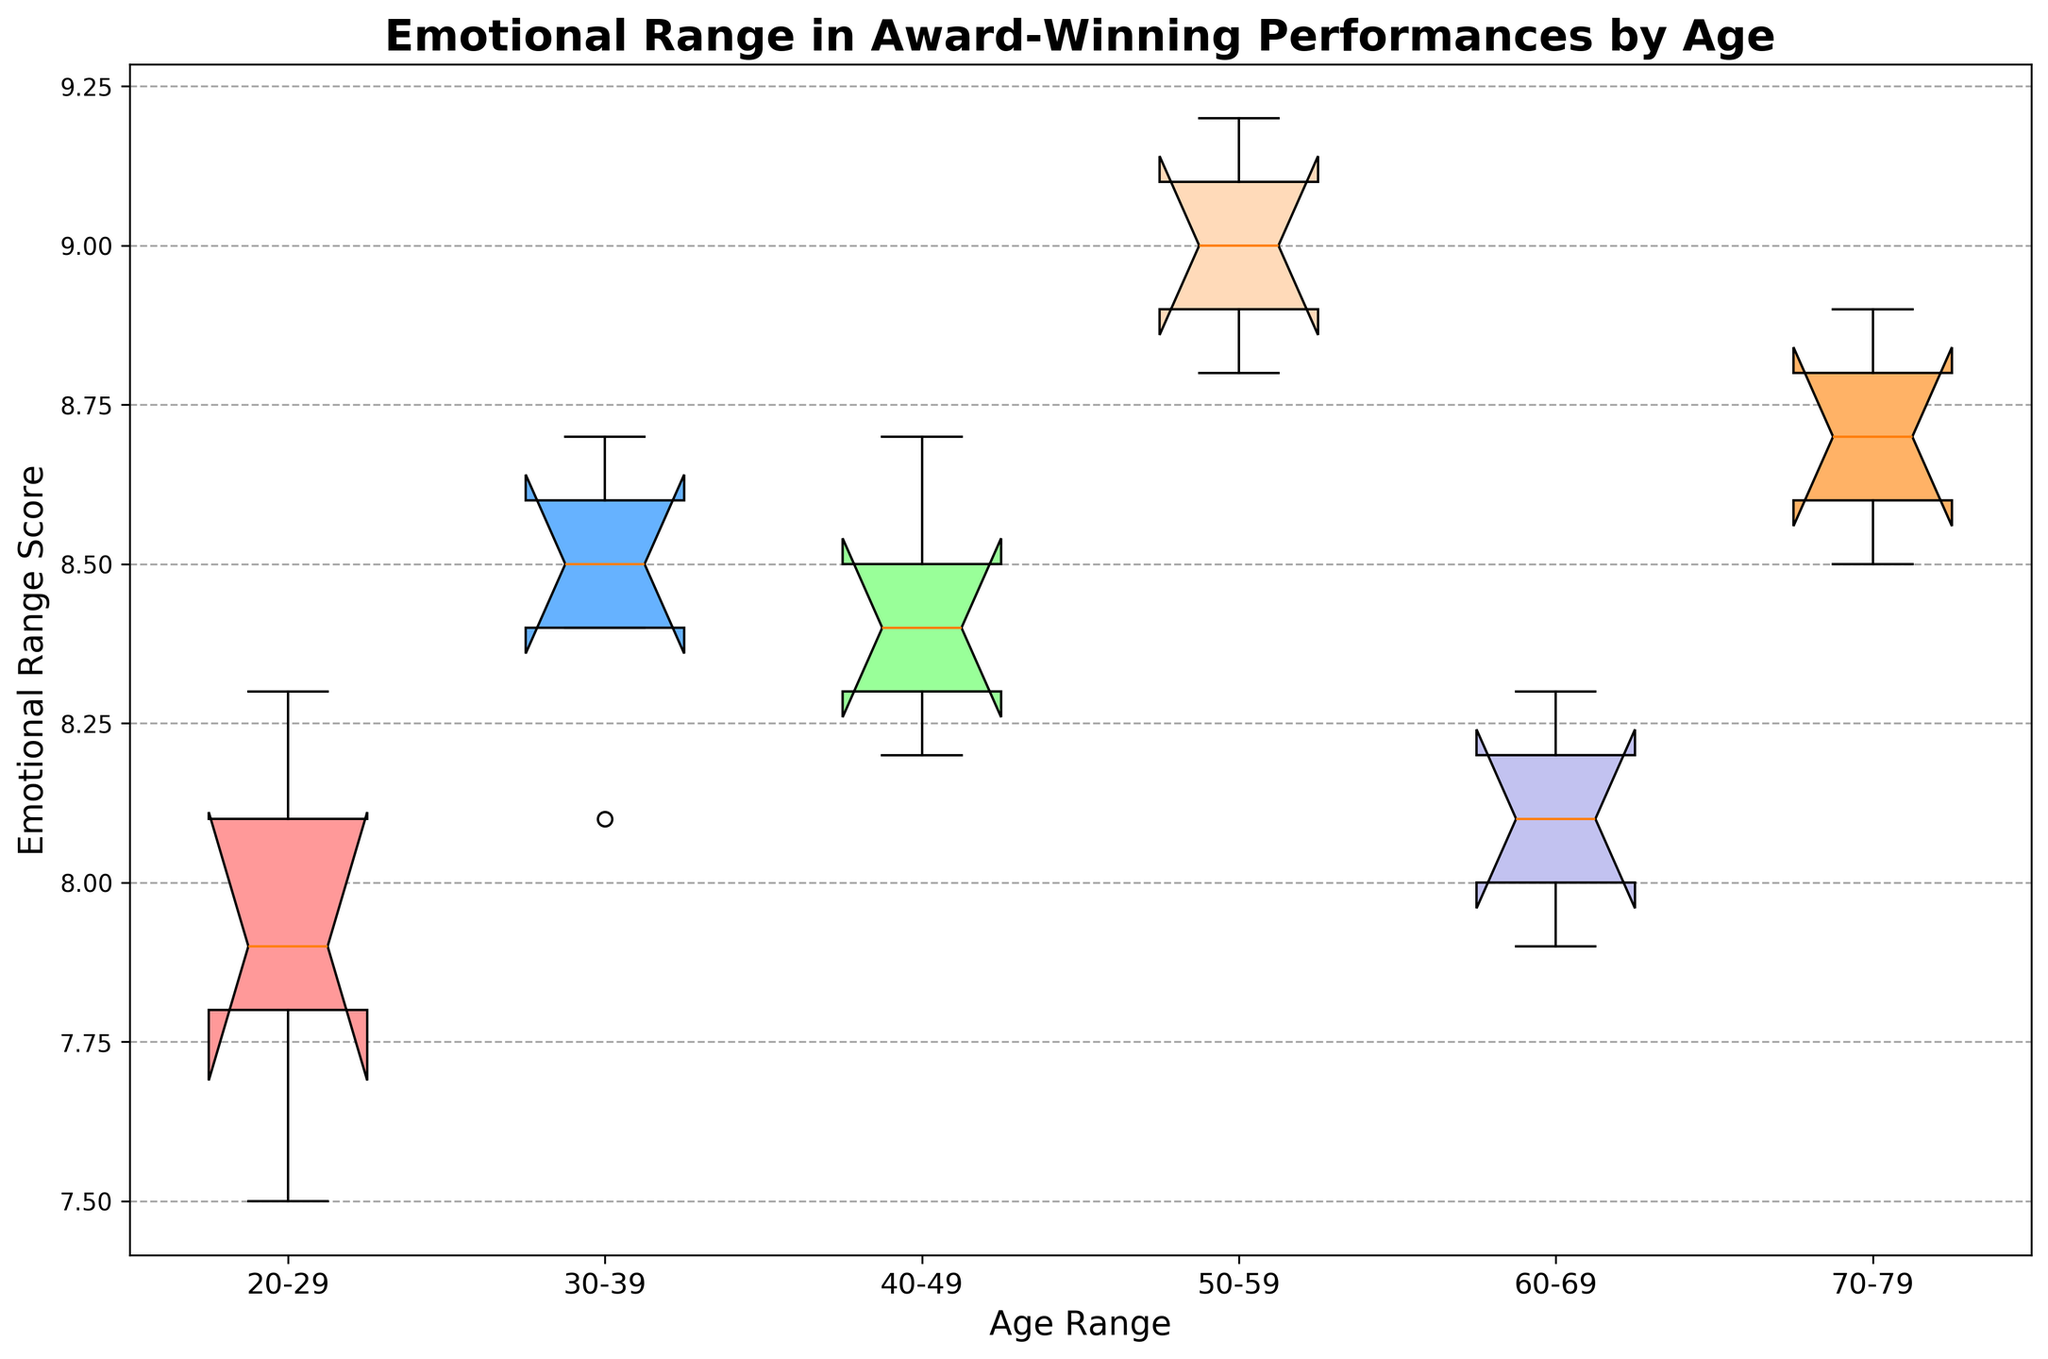What is the median Emotional Range Score for the 40-49 age group? The box plot will show the median value as the horizontal line within the box for the 40-49 age group
Answer: 8.4 Which age group has the highest median Emotional Range Score? Compare the position of the median lines across all age groups. The highest median will be for the 50-59 age group
Answer: 50-59 How does the range of emotional scores in the 20-29 age group compare to the 60-69 age group? Compare the lengths of the boxes for the 20-29 and 60-69 age groups. The longer the box, the larger the range
Answer: The range is slightly wider in the 20-29 group Which age group has the smallest range (Interquartile Range, IQR) of emotional scores? Look at all the boxes and identify the one that has the shortest height; this represents the smallest range
Answer: 30-39 Are there any outliers in the 50-59 age group? Check the 50-59 age group's box plot and see if there are any dots outside the whiskers that represent outliers
Answer: No Which age group has the widest IQR? Look at the boxes' heights to determine which one is the tallest, indicating the widest IQR
Answer: 70-79 Which age group exhibits the lowest Emotional Range Score? Identify the bottom of the whiskers across all the age groups and find the lowest point
Answer: 20-29 What is the median Emotional Range Score difference between the 50-59 and 60-69 age groups? Find the median values for both age groups from the box plot and calculate the difference
Answer: 0.7 Which age groups have overlapping IQRs? Examine the boxes to see which boxes partially or completely overlap with each other
Answer: Several groups overlap, including 40-49 with 50-59 and 60-69 with 70-79 